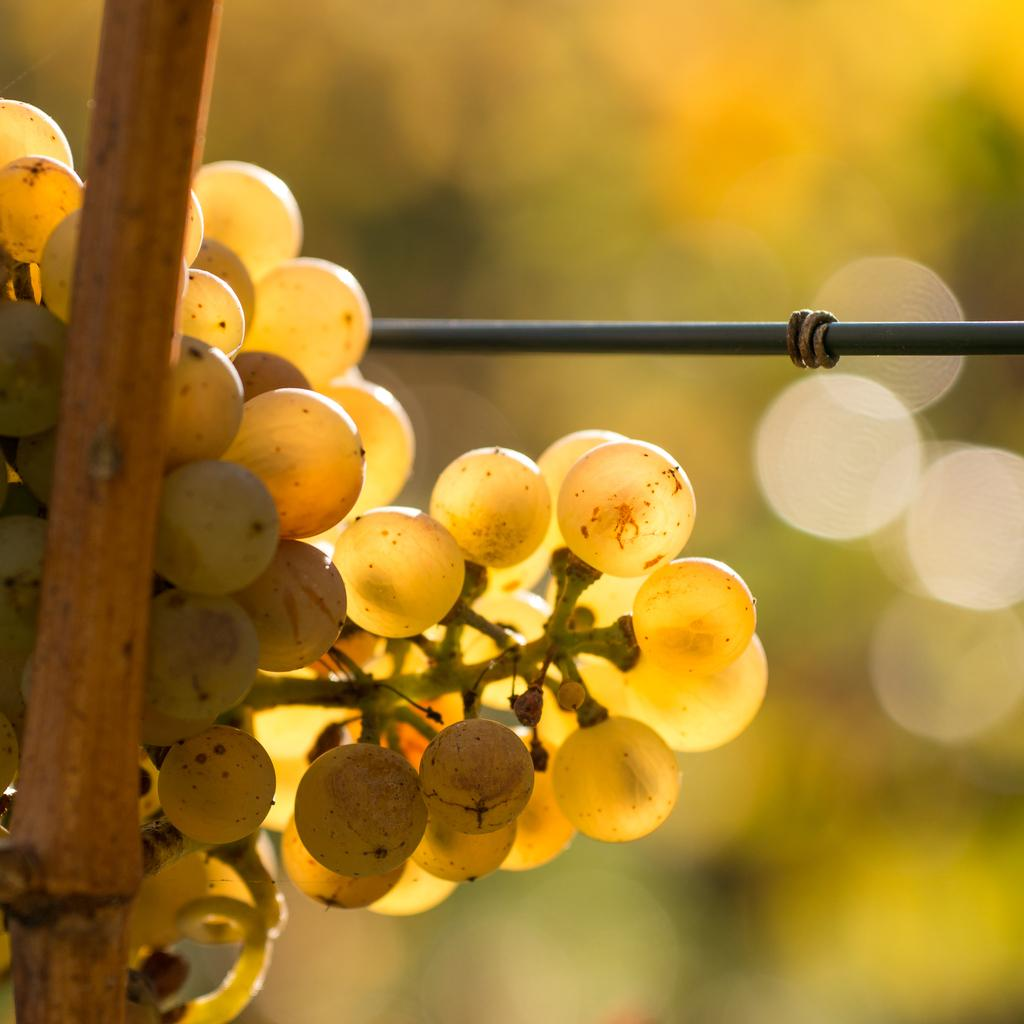What type of fruit is visible in the image? There is a bunch of grapes in the image. What object can be seen alongside the grapes? There is a stick in the image. What other item is present in the image? There is a wire in the image. What type of lace can be seen on the grapes in the image? There is no lace present on the grapes in the image. How does the steam escape from the grapes in the image? There is no steam present in the image, as it is a still image of grapes, a stick, and a wire. 